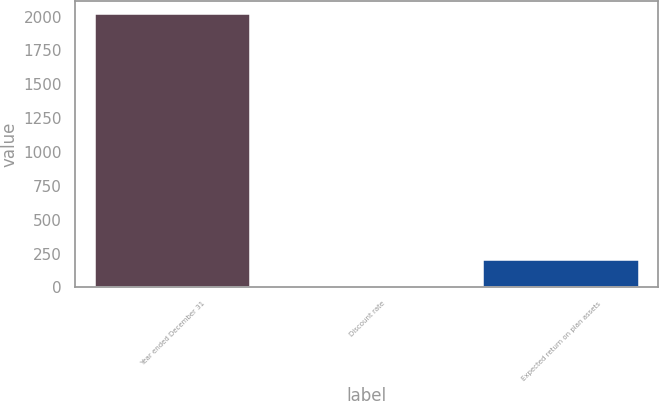Convert chart to OTSL. <chart><loc_0><loc_0><loc_500><loc_500><bar_chart><fcel>Year ended December 31<fcel>Discount rate<fcel>Expected return on plan assets<nl><fcel>2016<fcel>3.75<fcel>204.98<nl></chart> 